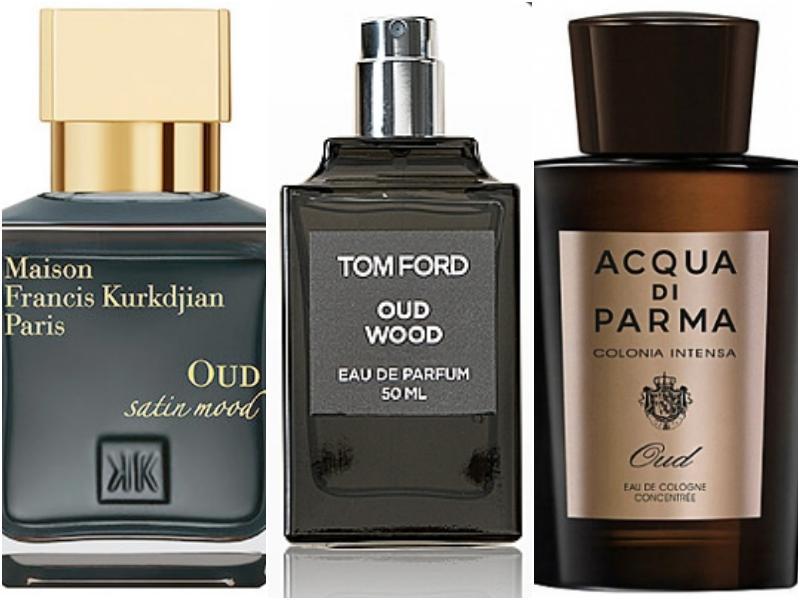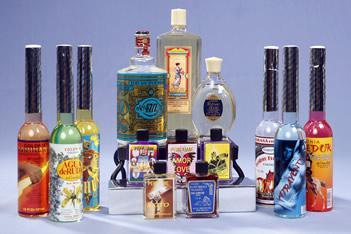The first image is the image on the left, the second image is the image on the right. For the images shown, is this caption "There are at most four perfume bottles in the left image." true? Answer yes or no. Yes. The first image is the image on the left, the second image is the image on the right. Examine the images to the left and right. Is the description "One of the images shows a corner area of a shop." accurate? Answer yes or no. No. 